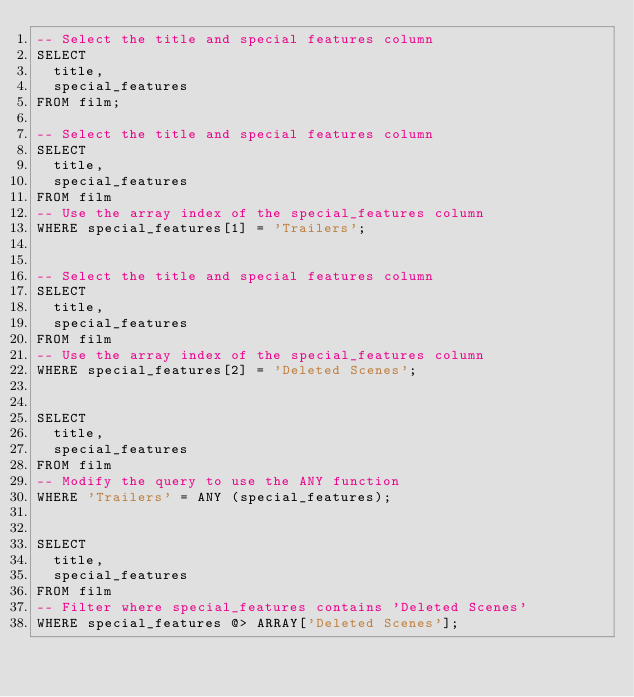<code> <loc_0><loc_0><loc_500><loc_500><_SQL_>-- Select the title and special features column 
SELECT 
  title, 
  special_features 
FROM film;

-- Select the title and special features column 
SELECT 
  title, 
  special_features 
FROM film
-- Use the array index of the special_features column
WHERE special_features[1] = 'Trailers';


-- Select the title and special features column 
SELECT 
  title, 
  special_features 
FROM film
-- Use the array index of the special_features column
WHERE special_features[2] = 'Deleted Scenes';


SELECT
  title, 
  special_features 
FROM film 
-- Modify the query to use the ANY function 
WHERE 'Trailers' = ANY (special_features);


SELECT 
  title, 
  special_features 
FROM film 
-- Filter where special_features contains 'Deleted Scenes'
WHERE special_features @> ARRAY['Deleted Scenes'];
</code> 